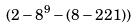<formula> <loc_0><loc_0><loc_500><loc_500>( 2 - 8 ^ { 9 } - ( 8 - 2 2 1 ) )</formula> 